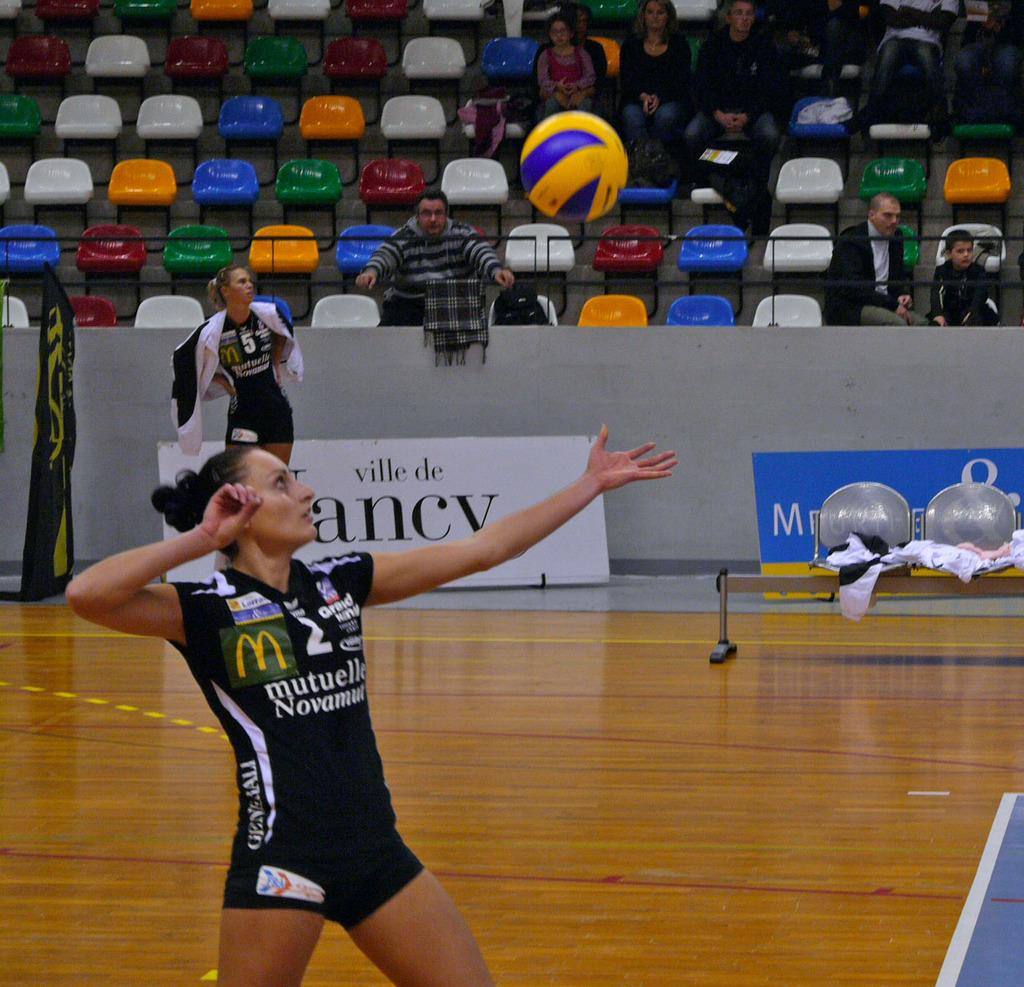<image>
Relay a brief, clear account of the picture shown. A volleyball player wearing a McDonalds and Mutuelle Novamut jersey goes to hit the ball while others watch. 